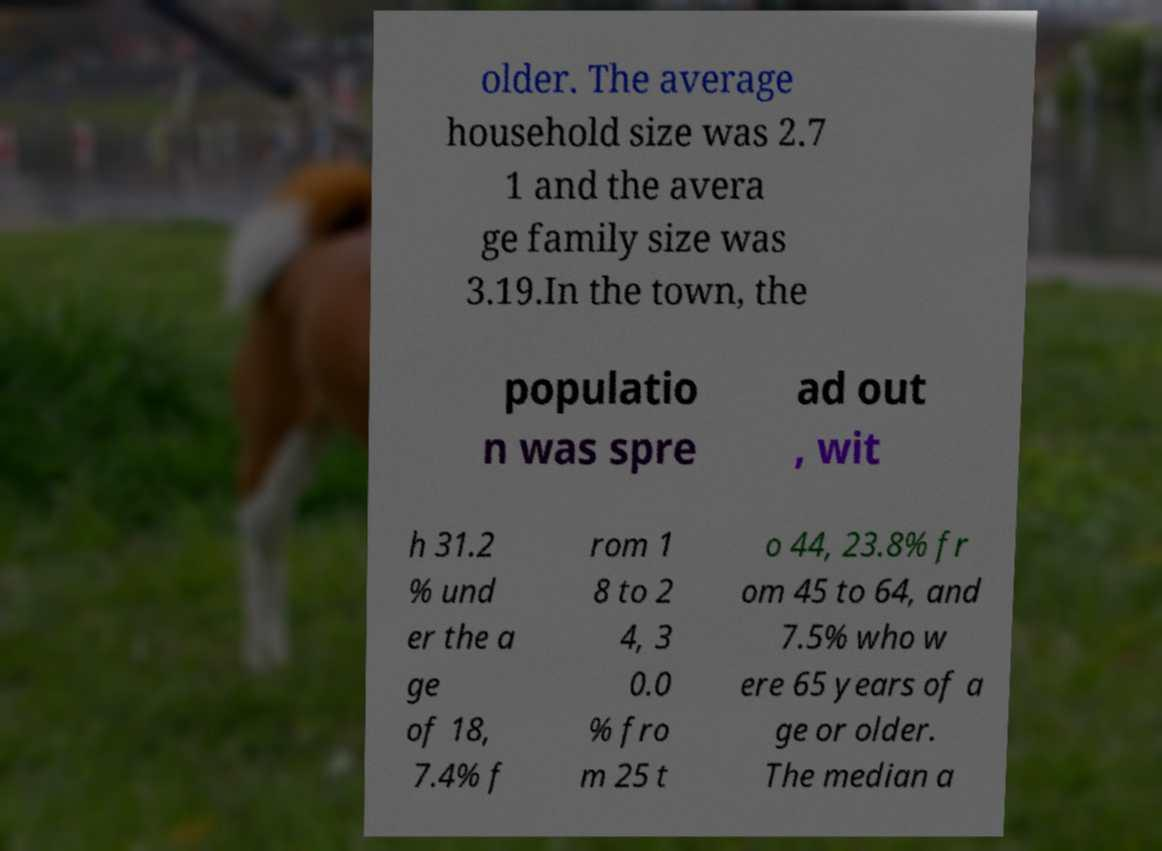I need the written content from this picture converted into text. Can you do that? older. The average household size was 2.7 1 and the avera ge family size was 3.19.In the town, the populatio n was spre ad out , wit h 31.2 % und er the a ge of 18, 7.4% f rom 1 8 to 2 4, 3 0.0 % fro m 25 t o 44, 23.8% fr om 45 to 64, and 7.5% who w ere 65 years of a ge or older. The median a 